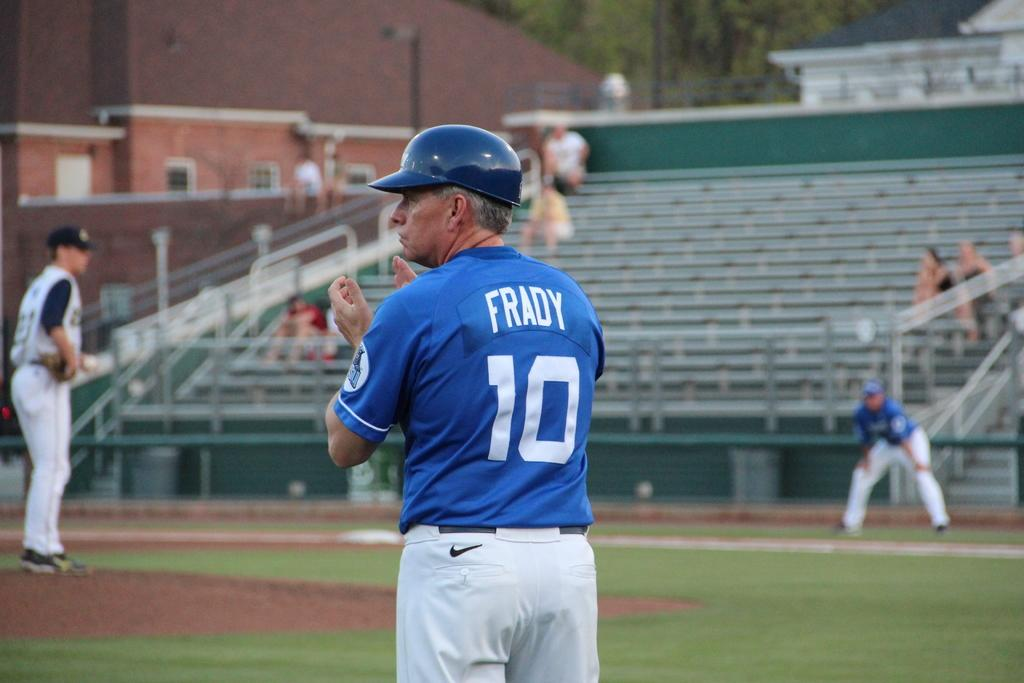<image>
Create a compact narrative representing the image presented. frady number 10 wearing a blue baseball jersery about to clap 